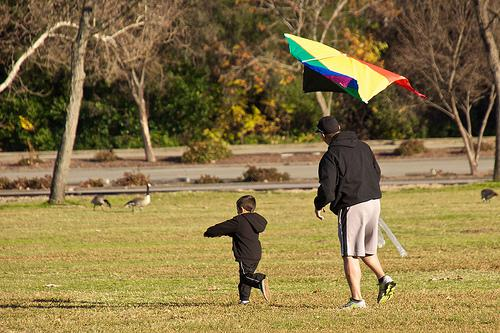Question: what are the people doing?
Choices:
A. Kayaking.
B. Sledding.
C. Driving.
D. Flying a kite.
Answer with the letter. Answer: D Question: why are they flying a kite?
Choices:
A. They were told to.
B. It is kite day.
C. They made the kite.
D. It is fun.
Answer with the letter. Answer: D Question: when is this taken?
Choices:
A. At dusk.
B. At sunrise.
C. Before noon.
D. During the day.
Answer with the letter. Answer: D 